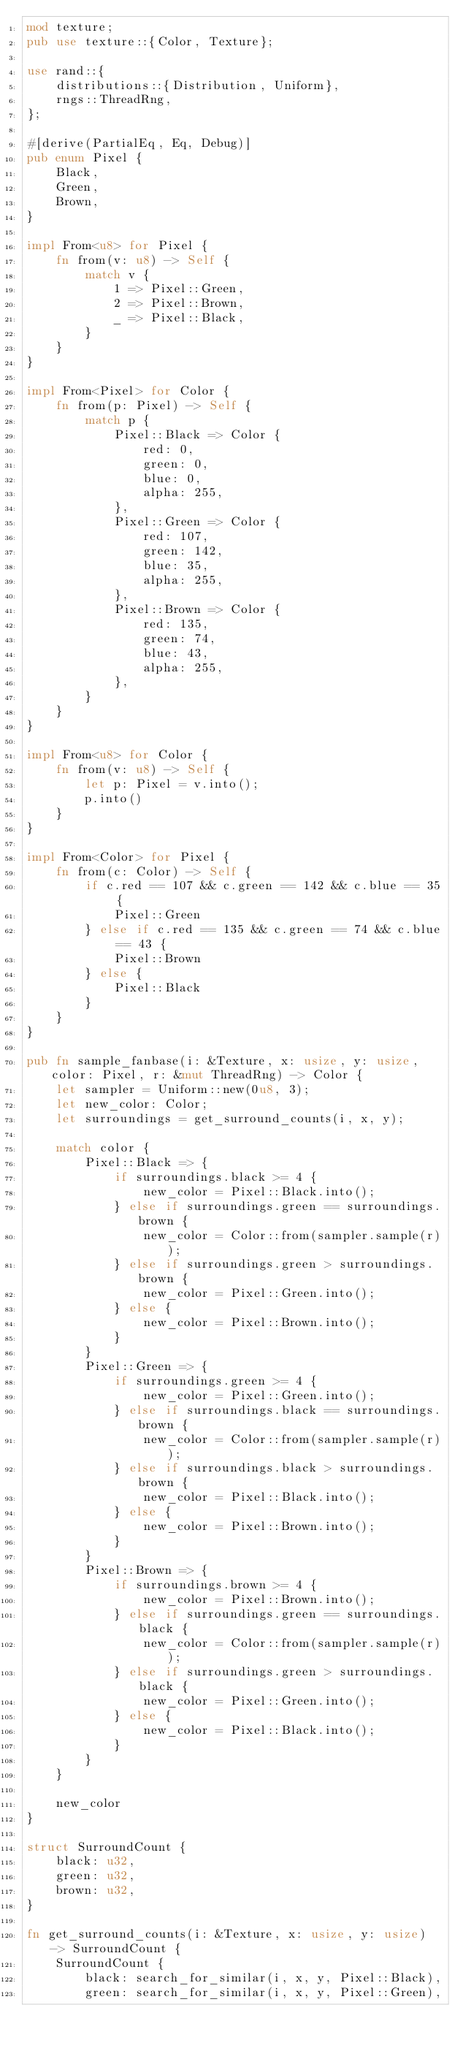Convert code to text. <code><loc_0><loc_0><loc_500><loc_500><_Rust_>mod texture;
pub use texture::{Color, Texture};

use rand::{
    distributions::{Distribution, Uniform},
    rngs::ThreadRng,
};

#[derive(PartialEq, Eq, Debug)]
pub enum Pixel {
    Black,
    Green,
    Brown,
}

impl From<u8> for Pixel {
    fn from(v: u8) -> Self {
        match v {
            1 => Pixel::Green,
            2 => Pixel::Brown,
            _ => Pixel::Black,
        }
    }
}

impl From<Pixel> for Color {
    fn from(p: Pixel) -> Self {
        match p {
            Pixel::Black => Color {
                red: 0,
                green: 0,
                blue: 0,
                alpha: 255,
            },
            Pixel::Green => Color {
                red: 107,
                green: 142,
                blue: 35,
                alpha: 255,
            },
            Pixel::Brown => Color {
                red: 135,
                green: 74,
                blue: 43,
                alpha: 255,
            },
        }
    }
}

impl From<u8> for Color {
    fn from(v: u8) -> Self {
        let p: Pixel = v.into();
        p.into()
    }
}

impl From<Color> for Pixel {
    fn from(c: Color) -> Self {
        if c.red == 107 && c.green == 142 && c.blue == 35 {
            Pixel::Green
        } else if c.red == 135 && c.green == 74 && c.blue == 43 {
            Pixel::Brown
        } else {
            Pixel::Black
        }
    }
}

pub fn sample_fanbase(i: &Texture, x: usize, y: usize, color: Pixel, r: &mut ThreadRng) -> Color {
    let sampler = Uniform::new(0u8, 3);
    let new_color: Color;
    let surroundings = get_surround_counts(i, x, y);

    match color {
        Pixel::Black => {
            if surroundings.black >= 4 {
                new_color = Pixel::Black.into();
            } else if surroundings.green == surroundings.brown {
                new_color = Color::from(sampler.sample(r));
            } else if surroundings.green > surroundings.brown {
                new_color = Pixel::Green.into();
            } else {
                new_color = Pixel::Brown.into();
            }
        }
        Pixel::Green => {
            if surroundings.green >= 4 {
                new_color = Pixel::Green.into();
            } else if surroundings.black == surroundings.brown {
                new_color = Color::from(sampler.sample(r));
            } else if surroundings.black > surroundings.brown {
                new_color = Pixel::Black.into();
            } else {
                new_color = Pixel::Brown.into();
            }
        }
        Pixel::Brown => {
            if surroundings.brown >= 4 {
                new_color = Pixel::Brown.into();
            } else if surroundings.green == surroundings.black {
                new_color = Color::from(sampler.sample(r));
            } else if surroundings.green > surroundings.black {
                new_color = Pixel::Green.into();
            } else {
                new_color = Pixel::Black.into();
            }
        }
    }

    new_color
}

struct SurroundCount {
    black: u32,
    green: u32,
    brown: u32,
}

fn get_surround_counts(i: &Texture, x: usize, y: usize) -> SurroundCount {
    SurroundCount {
        black: search_for_similar(i, x, y, Pixel::Black),
        green: search_for_similar(i, x, y, Pixel::Green),</code> 